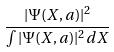Convert formula to latex. <formula><loc_0><loc_0><loc_500><loc_500>\frac { | \Psi ( X , a ) | ^ { 2 } } { \int | \Psi ( X , a ) | ^ { 2 } d X }</formula> 